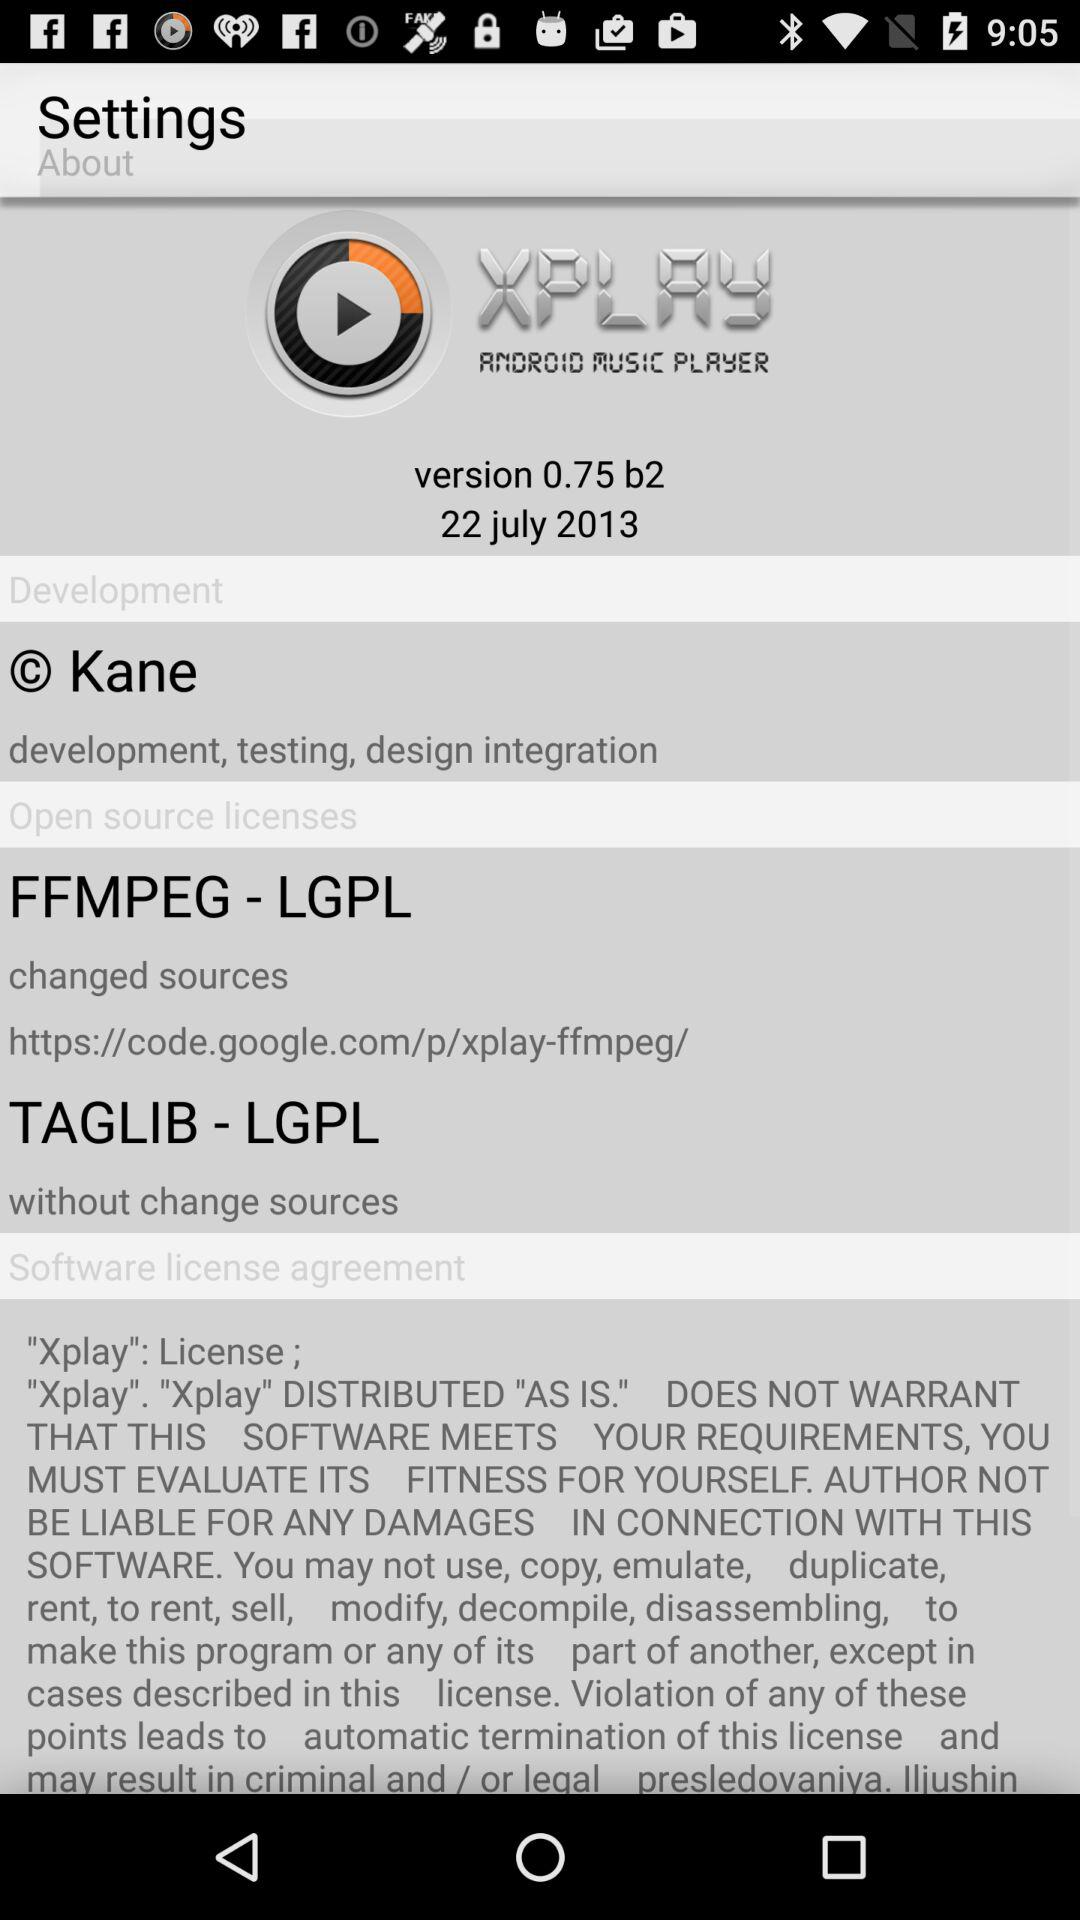What is the app name? The app name is "XPLAY". 